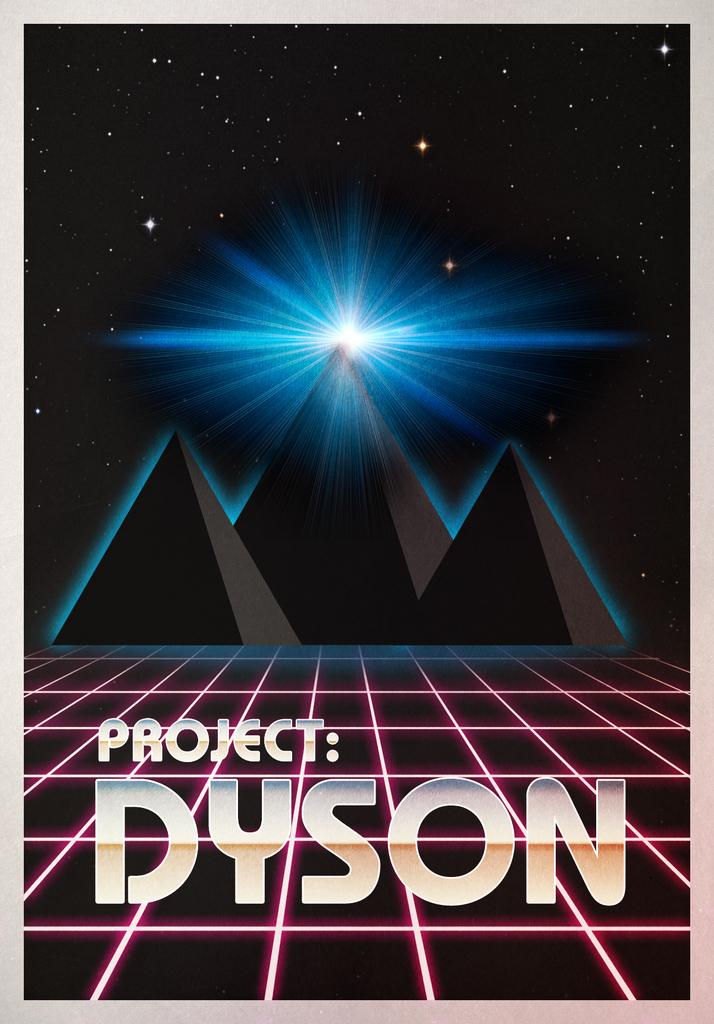<image>
Relay a brief, clear account of the picture shown. Poster showing some pyramids in the back and "Project:Dyson" in the front. 